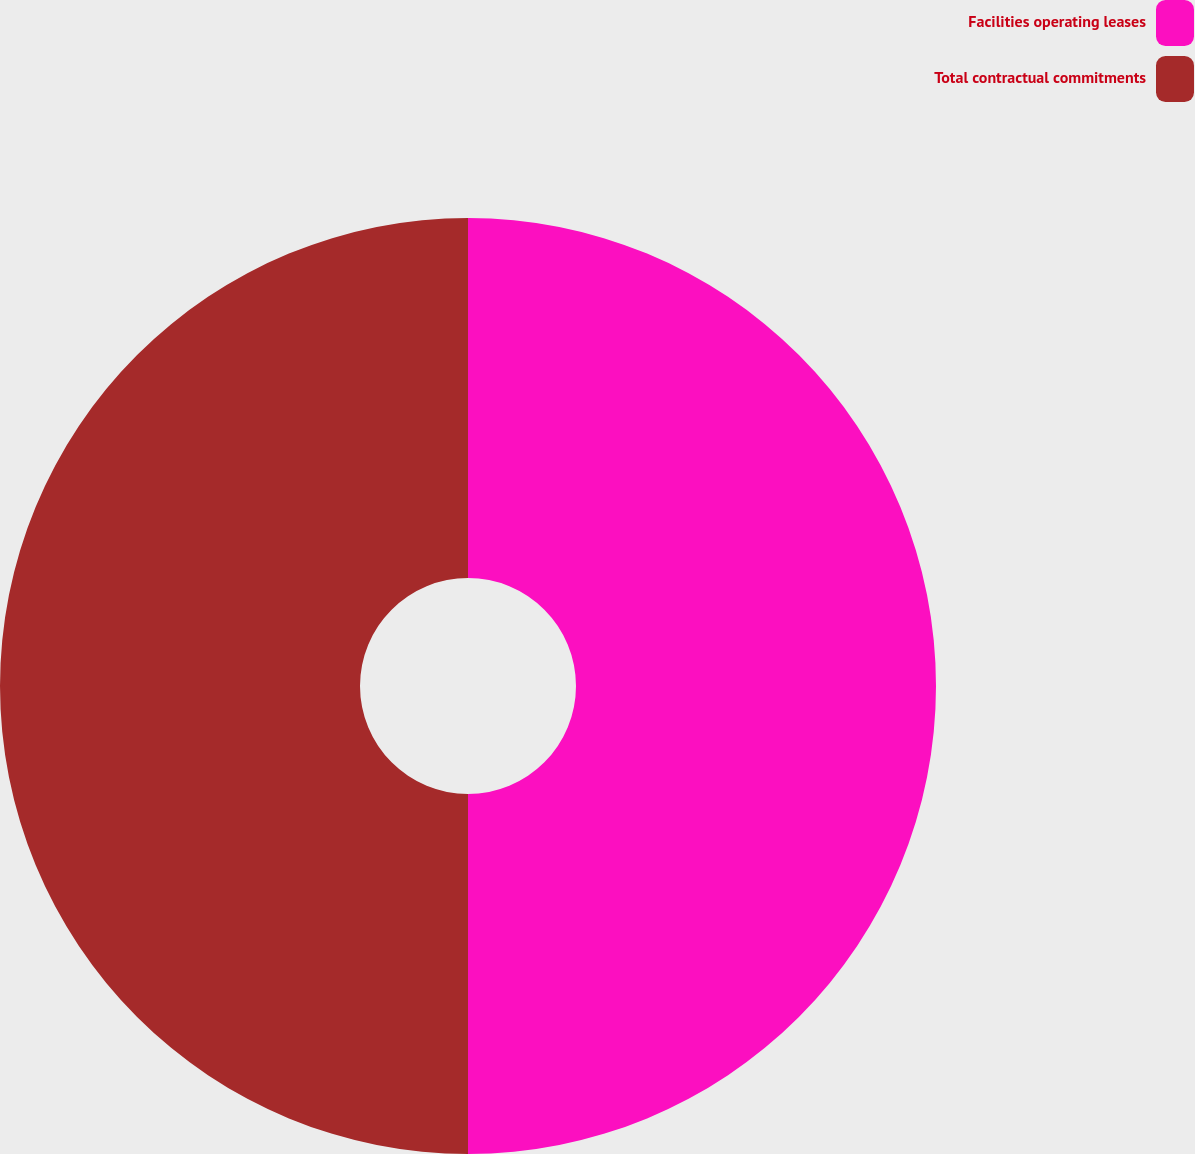Convert chart to OTSL. <chart><loc_0><loc_0><loc_500><loc_500><pie_chart><fcel>Facilities operating leases<fcel>Total contractual commitments<nl><fcel>50.0%<fcel>50.0%<nl></chart> 